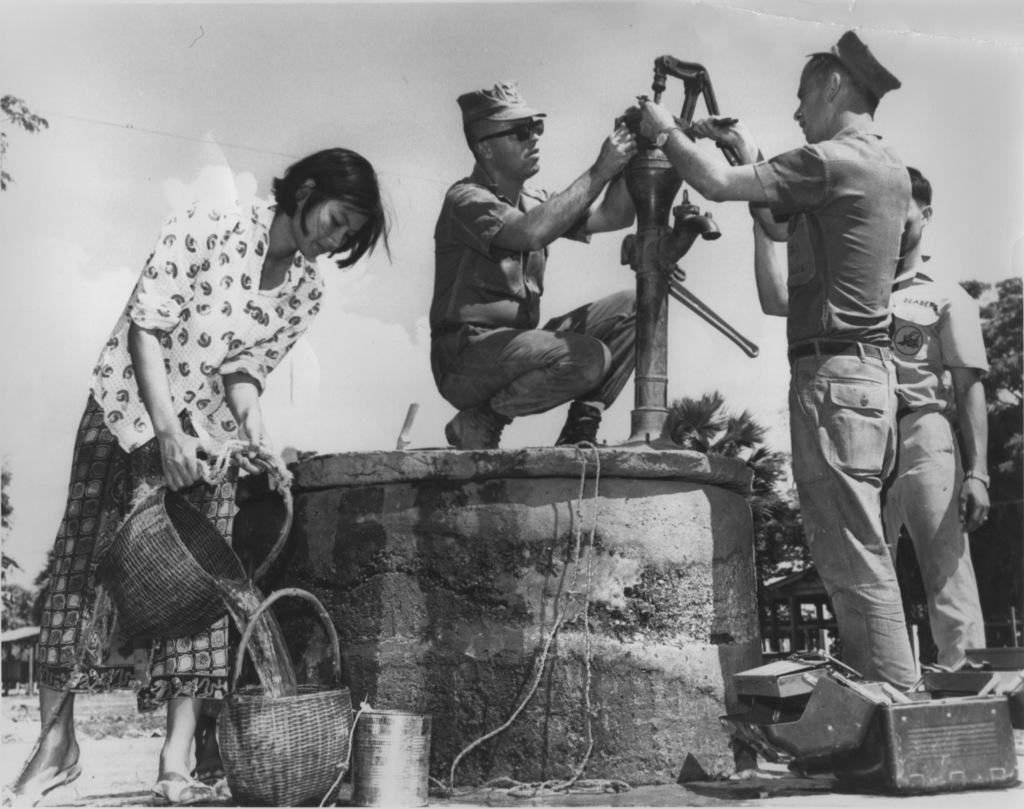What is the main object on the platform in the image? There is a hand pump on a platform in the image. What items are present near the hand pump? There are baskets, caps, and goggles visible in the image. Can you describe the water in the image? Yes, there is water visible in the image. What type of vegetation is present in the image? There are trees in the image. Are there any people in the image? Yes, there are people standing in the image. What is visible in the background of the image? The sky is visible in the background of the image. What type of ring can be seen on the hand pump in the image? There is no ring present on the hand pump in the image. What type of society is depicted in the image? The image does not depict a society; it shows a hand pump, baskets, caps, goggles, trees, people, and the sky. 